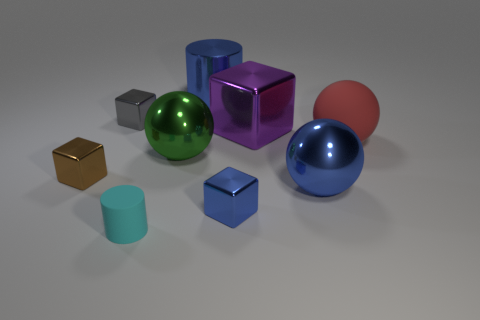Is the number of purple blocks that are in front of the large red ball the same as the number of large purple metallic things to the left of the cyan cylinder?
Your response must be concise. Yes. There is a cylinder that is on the left side of the big blue thing that is on the left side of the small object on the right side of the cyan thing; what color is it?
Provide a succinct answer. Cyan. There is a matte thing to the right of the small cyan rubber cylinder; what is its shape?
Your response must be concise. Sphere. There is a brown thing that is made of the same material as the tiny blue thing; what shape is it?
Offer a very short reply. Cube. Is there any other thing that is the same shape as the tiny cyan thing?
Offer a very short reply. Yes. There is a blue metallic cube; how many shiny blocks are in front of it?
Ensure brevity in your answer.  0. Is the number of gray metal things in front of the red ball the same as the number of tiny blue rubber things?
Keep it short and to the point. Yes. Is the material of the large red thing the same as the large green thing?
Give a very brief answer. No. How big is the shiny cube that is behind the big rubber object and on the left side of the big blue shiny cylinder?
Give a very brief answer. Small. What number of purple metal objects have the same size as the brown thing?
Provide a short and direct response. 0. 